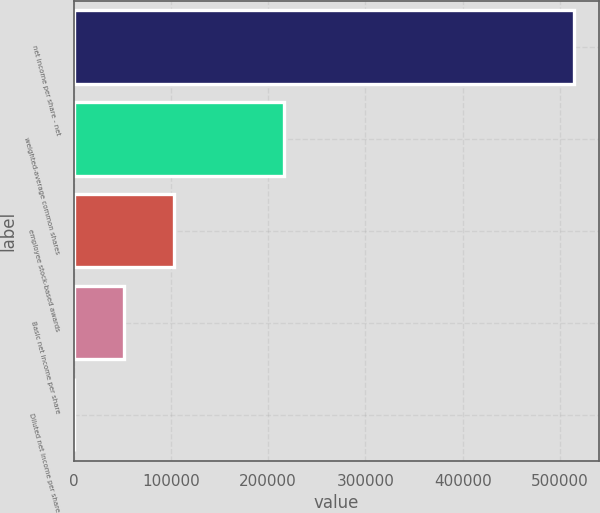<chart> <loc_0><loc_0><loc_500><loc_500><bar_chart><fcel>net income per share - net<fcel>weighted-average common shares<fcel>employee stock-based awards<fcel>Basic net income per share<fcel>Diluted net income per share<nl><fcel>514123<fcel>216340<fcel>102826<fcel>51414.4<fcel>2.35<nl></chart> 